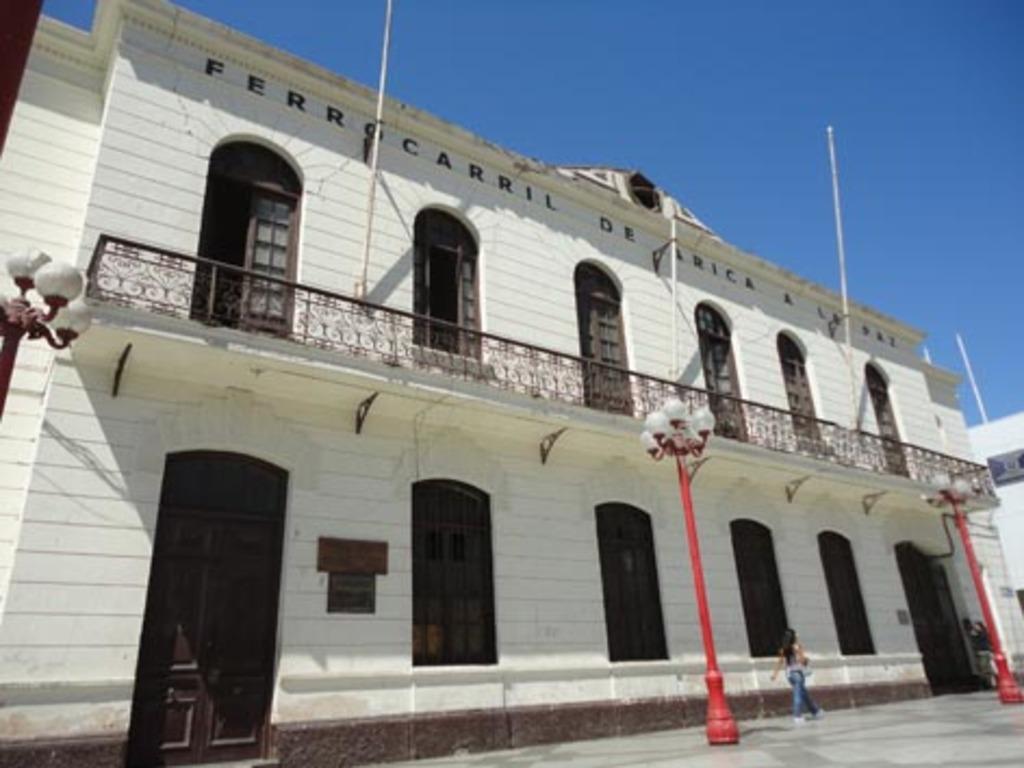Could you give a brief overview of what you see in this image? In this picture, we see a building in white color. It has an iron railing and the poles. We even see windows and a door. In front of the picture, we see light poles. The woman in blue jeans is walking. At the top, we see the sky, which is blue in color. 